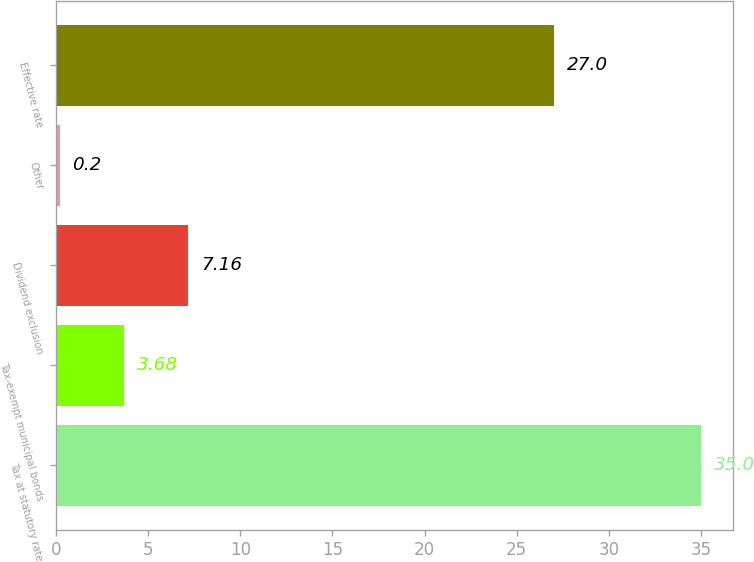Convert chart to OTSL. <chart><loc_0><loc_0><loc_500><loc_500><bar_chart><fcel>Tax at statutory rate<fcel>Tax-exempt municipal bonds<fcel>Dividend exclusion<fcel>Other<fcel>Effective rate<nl><fcel>35<fcel>3.68<fcel>7.16<fcel>0.2<fcel>27<nl></chart> 